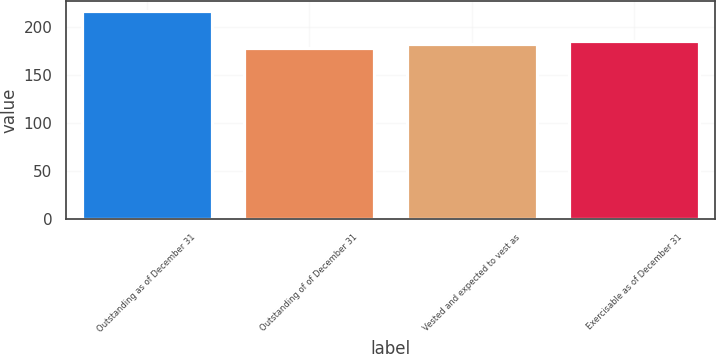Convert chart. <chart><loc_0><loc_0><loc_500><loc_500><bar_chart><fcel>Outstanding as of December 31<fcel>Outstanding of of December 31<fcel>Vested and expected to vest as<fcel>Exercisable as of December 31<nl><fcel>216<fcel>178<fcel>181.8<fcel>185.6<nl></chart> 